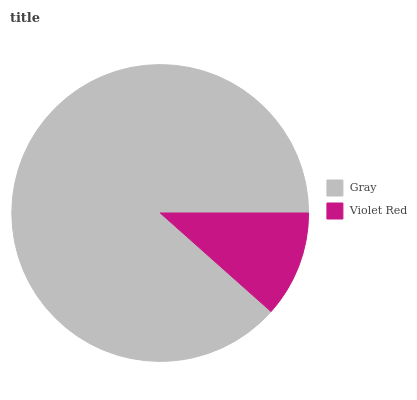Is Violet Red the minimum?
Answer yes or no. Yes. Is Gray the maximum?
Answer yes or no. Yes. Is Violet Red the maximum?
Answer yes or no. No. Is Gray greater than Violet Red?
Answer yes or no. Yes. Is Violet Red less than Gray?
Answer yes or no. Yes. Is Violet Red greater than Gray?
Answer yes or no. No. Is Gray less than Violet Red?
Answer yes or no. No. Is Gray the high median?
Answer yes or no. Yes. Is Violet Red the low median?
Answer yes or no. Yes. Is Violet Red the high median?
Answer yes or no. No. Is Gray the low median?
Answer yes or no. No. 